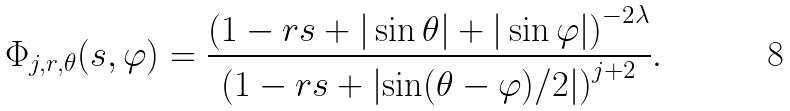Convert formula to latex. <formula><loc_0><loc_0><loc_500><loc_500>\Phi _ { j , r , \theta } ( s , \varphi ) = \frac { \left ( 1 - r s + | \sin \theta | + | \sin \varphi | \right ) ^ { - 2 \lambda } } { \left ( 1 - r s + \left | \sin ( \theta - \varphi ) / 2 \right | \right ) ^ { j + 2 } } .</formula> 